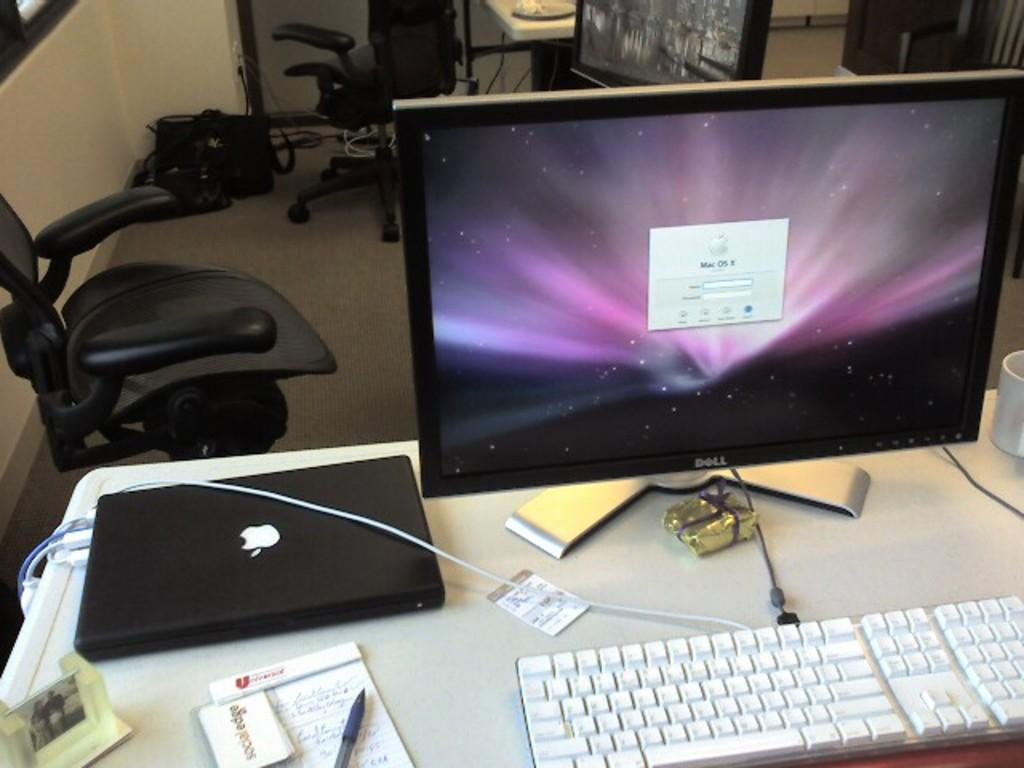<image>
Render a clear and concise summary of the photo. A black Apple laptop with monitor on the side 